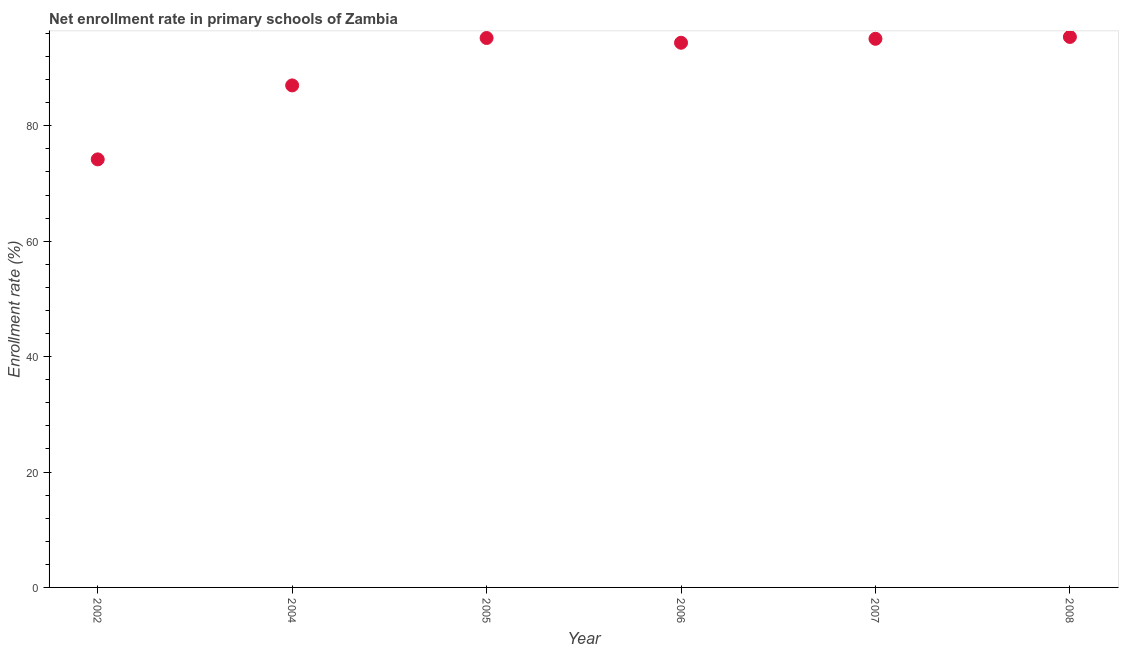What is the net enrollment rate in primary schools in 2008?
Offer a very short reply. 95.4. Across all years, what is the maximum net enrollment rate in primary schools?
Your answer should be compact. 95.4. Across all years, what is the minimum net enrollment rate in primary schools?
Offer a very short reply. 74.18. What is the sum of the net enrollment rate in primary schools?
Offer a very short reply. 541.27. What is the difference between the net enrollment rate in primary schools in 2007 and 2008?
Offer a very short reply. -0.32. What is the average net enrollment rate in primary schools per year?
Provide a short and direct response. 90.21. What is the median net enrollment rate in primary schools?
Ensure brevity in your answer.  94.74. In how many years, is the net enrollment rate in primary schools greater than 28 %?
Offer a very short reply. 6. Do a majority of the years between 2005 and 2004 (inclusive) have net enrollment rate in primary schools greater than 28 %?
Ensure brevity in your answer.  No. What is the ratio of the net enrollment rate in primary schools in 2006 to that in 2008?
Your answer should be very brief. 0.99. What is the difference between the highest and the second highest net enrollment rate in primary schools?
Give a very brief answer. 0.18. Is the sum of the net enrollment rate in primary schools in 2004 and 2007 greater than the maximum net enrollment rate in primary schools across all years?
Offer a terse response. Yes. What is the difference between the highest and the lowest net enrollment rate in primary schools?
Offer a very short reply. 21.22. In how many years, is the net enrollment rate in primary schools greater than the average net enrollment rate in primary schools taken over all years?
Make the answer very short. 4. Does the net enrollment rate in primary schools monotonically increase over the years?
Offer a terse response. No. How many dotlines are there?
Provide a short and direct response. 1. How many years are there in the graph?
Offer a terse response. 6. Does the graph contain any zero values?
Make the answer very short. No. What is the title of the graph?
Keep it short and to the point. Net enrollment rate in primary schools of Zambia. What is the label or title of the X-axis?
Your response must be concise. Year. What is the label or title of the Y-axis?
Give a very brief answer. Enrollment rate (%). What is the Enrollment rate (%) in 2002?
Your response must be concise. 74.18. What is the Enrollment rate (%) in 2004?
Keep it short and to the point. 87. What is the Enrollment rate (%) in 2005?
Provide a succinct answer. 95.22. What is the Enrollment rate (%) in 2006?
Offer a terse response. 94.39. What is the Enrollment rate (%) in 2007?
Give a very brief answer. 95.08. What is the Enrollment rate (%) in 2008?
Your response must be concise. 95.4. What is the difference between the Enrollment rate (%) in 2002 and 2004?
Make the answer very short. -12.82. What is the difference between the Enrollment rate (%) in 2002 and 2005?
Offer a terse response. -21.04. What is the difference between the Enrollment rate (%) in 2002 and 2006?
Keep it short and to the point. -20.21. What is the difference between the Enrollment rate (%) in 2002 and 2007?
Offer a very short reply. -20.9. What is the difference between the Enrollment rate (%) in 2002 and 2008?
Offer a very short reply. -21.22. What is the difference between the Enrollment rate (%) in 2004 and 2005?
Provide a succinct answer. -8.22. What is the difference between the Enrollment rate (%) in 2004 and 2006?
Provide a short and direct response. -7.39. What is the difference between the Enrollment rate (%) in 2004 and 2007?
Make the answer very short. -8.08. What is the difference between the Enrollment rate (%) in 2004 and 2008?
Your answer should be compact. -8.4. What is the difference between the Enrollment rate (%) in 2005 and 2006?
Your response must be concise. 0.82. What is the difference between the Enrollment rate (%) in 2005 and 2007?
Make the answer very short. 0.14. What is the difference between the Enrollment rate (%) in 2005 and 2008?
Offer a terse response. -0.18. What is the difference between the Enrollment rate (%) in 2006 and 2007?
Your answer should be compact. -0.68. What is the difference between the Enrollment rate (%) in 2006 and 2008?
Ensure brevity in your answer.  -1.01. What is the difference between the Enrollment rate (%) in 2007 and 2008?
Your response must be concise. -0.32. What is the ratio of the Enrollment rate (%) in 2002 to that in 2004?
Provide a short and direct response. 0.85. What is the ratio of the Enrollment rate (%) in 2002 to that in 2005?
Give a very brief answer. 0.78. What is the ratio of the Enrollment rate (%) in 2002 to that in 2006?
Provide a short and direct response. 0.79. What is the ratio of the Enrollment rate (%) in 2002 to that in 2007?
Your response must be concise. 0.78. What is the ratio of the Enrollment rate (%) in 2002 to that in 2008?
Offer a terse response. 0.78. What is the ratio of the Enrollment rate (%) in 2004 to that in 2005?
Provide a short and direct response. 0.91. What is the ratio of the Enrollment rate (%) in 2004 to that in 2006?
Keep it short and to the point. 0.92. What is the ratio of the Enrollment rate (%) in 2004 to that in 2007?
Ensure brevity in your answer.  0.92. What is the ratio of the Enrollment rate (%) in 2004 to that in 2008?
Your answer should be very brief. 0.91. What is the ratio of the Enrollment rate (%) in 2005 to that in 2007?
Give a very brief answer. 1. What is the ratio of the Enrollment rate (%) in 2006 to that in 2008?
Ensure brevity in your answer.  0.99. 